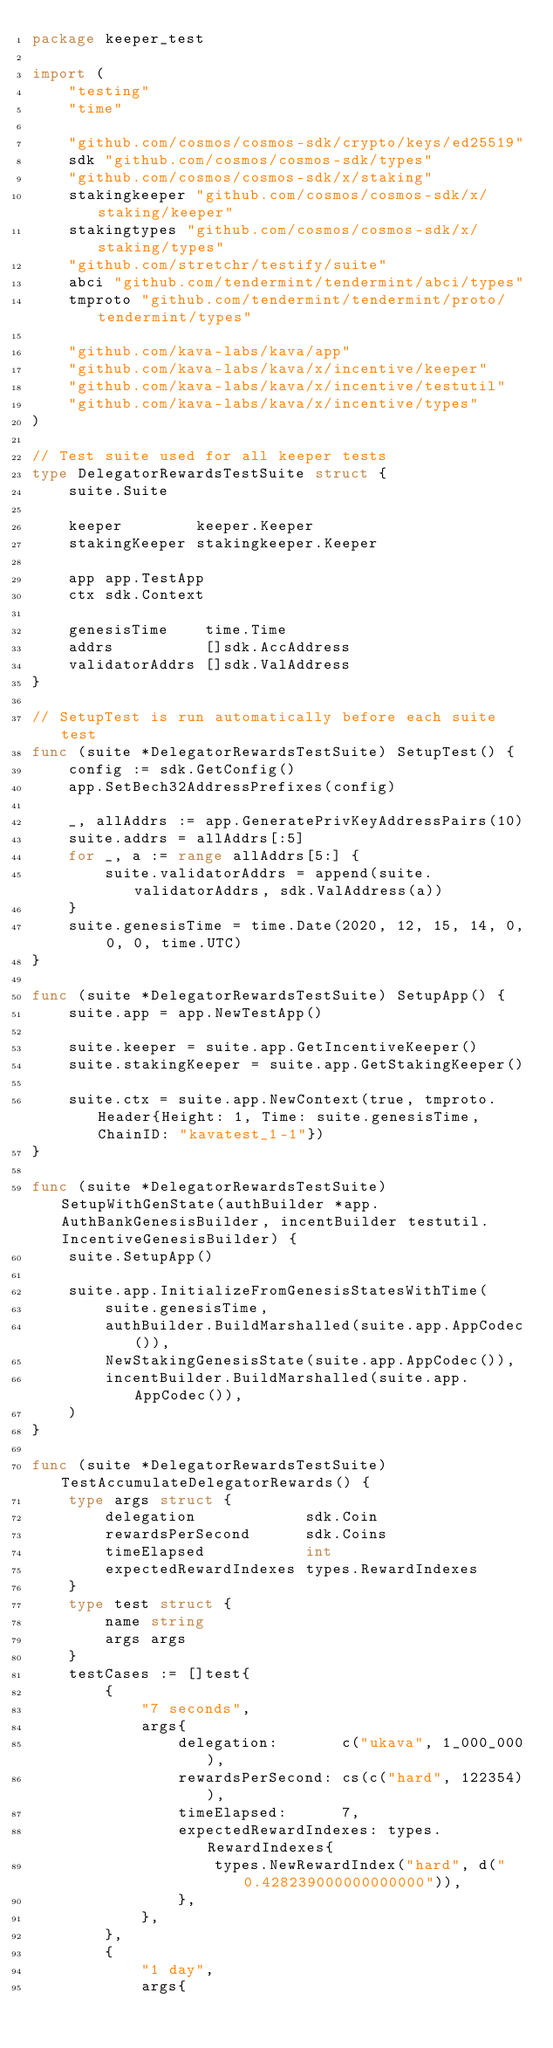Convert code to text. <code><loc_0><loc_0><loc_500><loc_500><_Go_>package keeper_test

import (
	"testing"
	"time"

	"github.com/cosmos/cosmos-sdk/crypto/keys/ed25519"
	sdk "github.com/cosmos/cosmos-sdk/types"
	"github.com/cosmos/cosmos-sdk/x/staking"
	stakingkeeper "github.com/cosmos/cosmos-sdk/x/staking/keeper"
	stakingtypes "github.com/cosmos/cosmos-sdk/x/staking/types"
	"github.com/stretchr/testify/suite"
	abci "github.com/tendermint/tendermint/abci/types"
	tmproto "github.com/tendermint/tendermint/proto/tendermint/types"

	"github.com/kava-labs/kava/app"
	"github.com/kava-labs/kava/x/incentive/keeper"
	"github.com/kava-labs/kava/x/incentive/testutil"
	"github.com/kava-labs/kava/x/incentive/types"
)

// Test suite used for all keeper tests
type DelegatorRewardsTestSuite struct {
	suite.Suite

	keeper        keeper.Keeper
	stakingKeeper stakingkeeper.Keeper

	app app.TestApp
	ctx sdk.Context

	genesisTime    time.Time
	addrs          []sdk.AccAddress
	validatorAddrs []sdk.ValAddress
}

// SetupTest is run automatically before each suite test
func (suite *DelegatorRewardsTestSuite) SetupTest() {
	config := sdk.GetConfig()
	app.SetBech32AddressPrefixes(config)

	_, allAddrs := app.GeneratePrivKeyAddressPairs(10)
	suite.addrs = allAddrs[:5]
	for _, a := range allAddrs[5:] {
		suite.validatorAddrs = append(suite.validatorAddrs, sdk.ValAddress(a))
	}
	suite.genesisTime = time.Date(2020, 12, 15, 14, 0, 0, 0, time.UTC)
}

func (suite *DelegatorRewardsTestSuite) SetupApp() {
	suite.app = app.NewTestApp()

	suite.keeper = suite.app.GetIncentiveKeeper()
	suite.stakingKeeper = suite.app.GetStakingKeeper()

	suite.ctx = suite.app.NewContext(true, tmproto.Header{Height: 1, Time: suite.genesisTime, ChainID: "kavatest_1-1"})
}

func (suite *DelegatorRewardsTestSuite) SetupWithGenState(authBuilder *app.AuthBankGenesisBuilder, incentBuilder testutil.IncentiveGenesisBuilder) {
	suite.SetupApp()

	suite.app.InitializeFromGenesisStatesWithTime(
		suite.genesisTime,
		authBuilder.BuildMarshalled(suite.app.AppCodec()),
		NewStakingGenesisState(suite.app.AppCodec()),
		incentBuilder.BuildMarshalled(suite.app.AppCodec()),
	)
}

func (suite *DelegatorRewardsTestSuite) TestAccumulateDelegatorRewards() {
	type args struct {
		delegation            sdk.Coin
		rewardsPerSecond      sdk.Coins
		timeElapsed           int
		expectedRewardIndexes types.RewardIndexes
	}
	type test struct {
		name string
		args args
	}
	testCases := []test{
		{
			"7 seconds",
			args{
				delegation:       c("ukava", 1_000_000),
				rewardsPerSecond: cs(c("hard", 122354)),
				timeElapsed:      7,
				expectedRewardIndexes: types.RewardIndexes{
					types.NewRewardIndex("hard", d("0.428239000000000000")),
				},
			},
		},
		{
			"1 day",
			args{</code> 